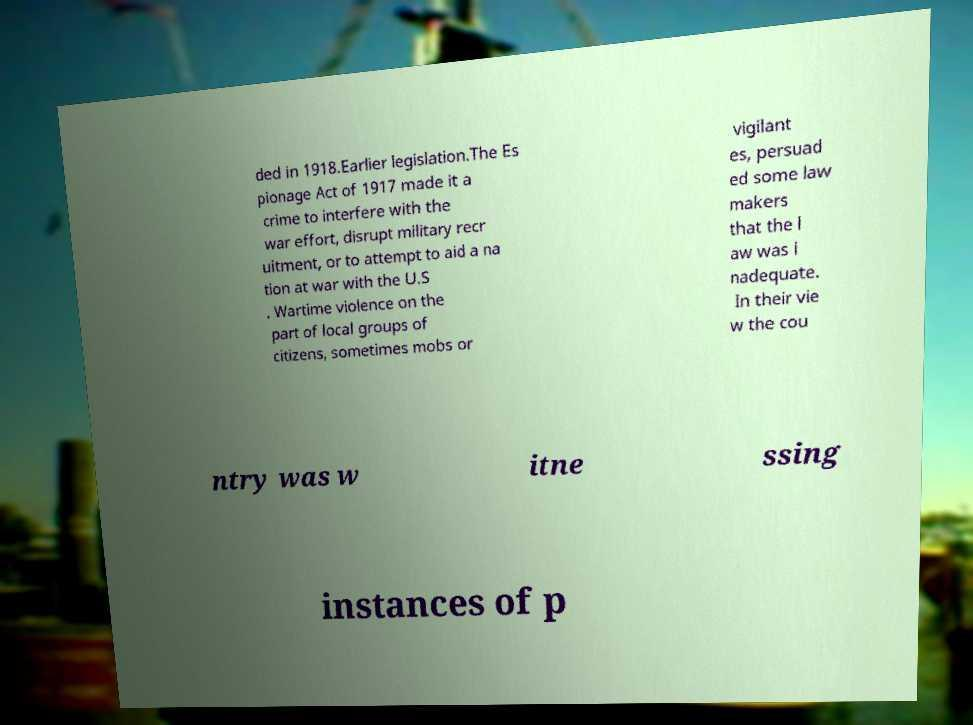Can you read and provide the text displayed in the image?This photo seems to have some interesting text. Can you extract and type it out for me? ded in 1918.Earlier legislation.The Es pionage Act of 1917 made it a crime to interfere with the war effort, disrupt military recr uitment, or to attempt to aid a na tion at war with the U.S . Wartime violence on the part of local groups of citizens, sometimes mobs or vigilant es, persuad ed some law makers that the l aw was i nadequate. In their vie w the cou ntry was w itne ssing instances of p 